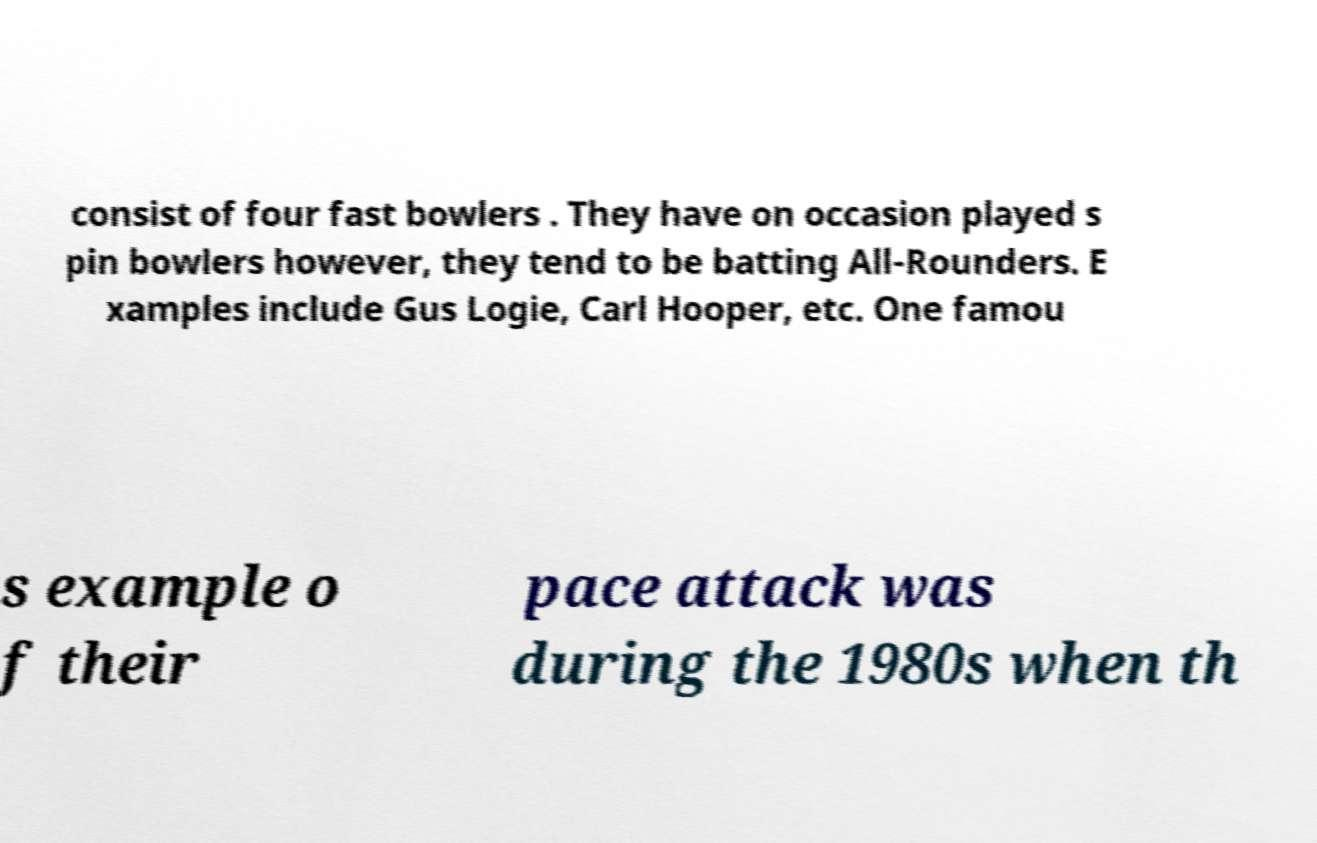Can you accurately transcribe the text from the provided image for me? consist of four fast bowlers . They have on occasion played s pin bowlers however, they tend to be batting All-Rounders. E xamples include Gus Logie, Carl Hooper, etc. One famou s example o f their pace attack was during the 1980s when th 